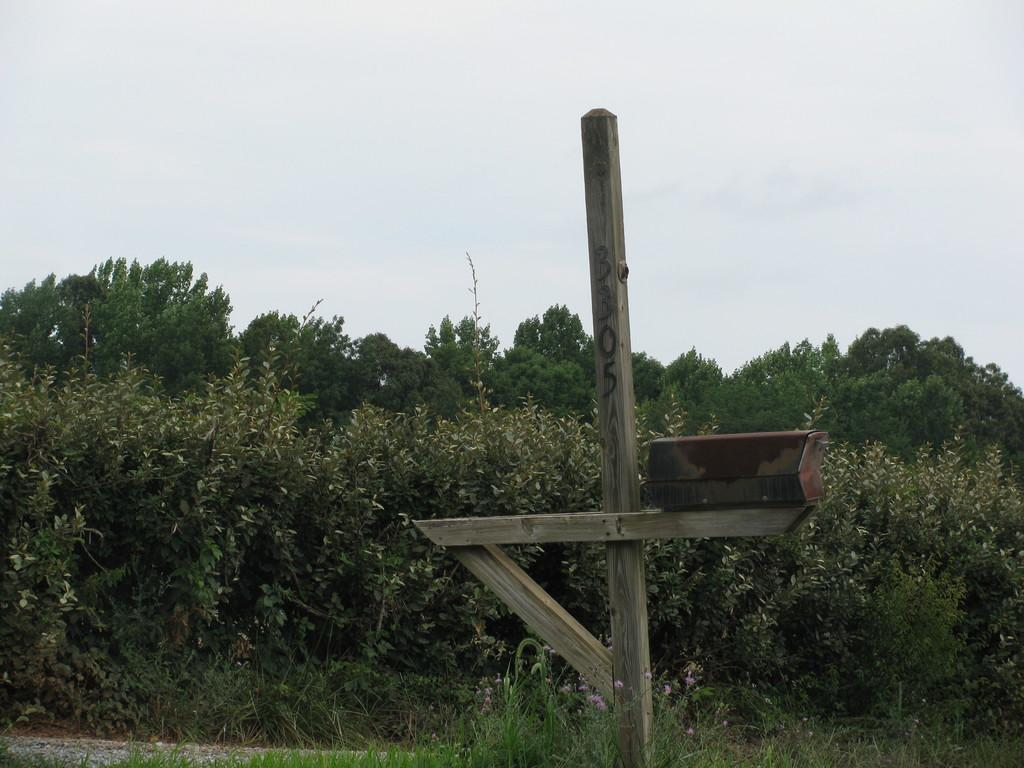What object made of wood can be seen in the image? There is a wooden stick in the image. What type of natural vegetation is present in the image? There are trees in the image. What is the condition of the sky in the image? The sky is cloudy in the image. What type of drain is visible in the image? There is no drain present in the image. Who is the authority figure in the image? There is no authority figure present in the image. 